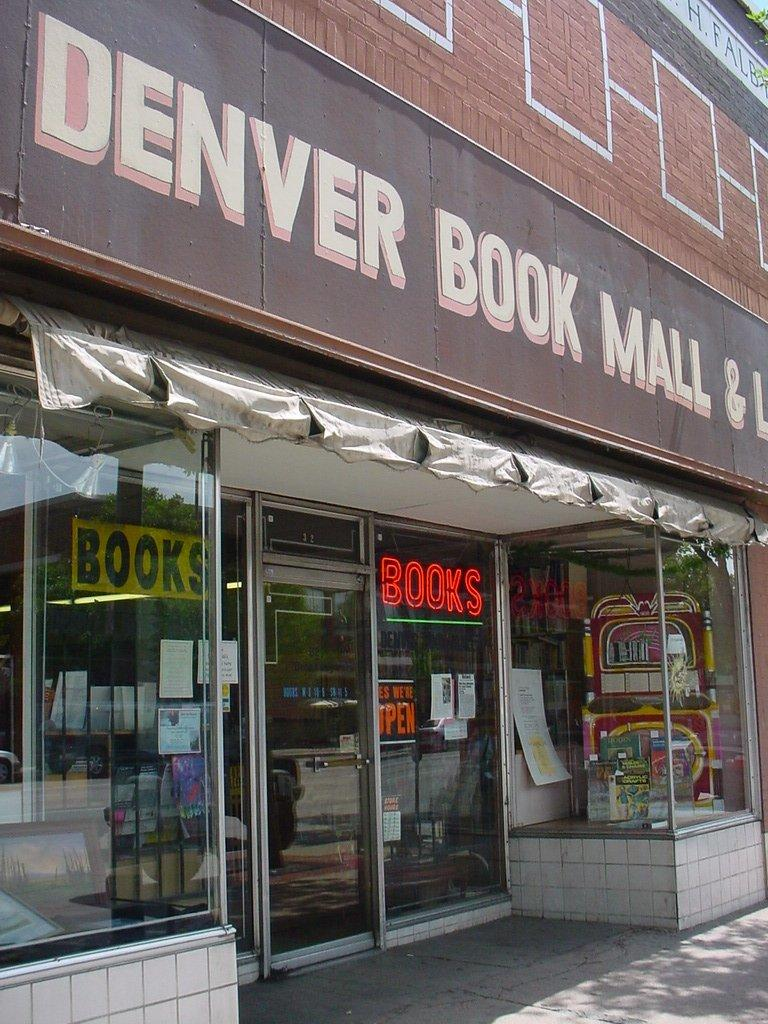<image>
Create a compact narrative representing the image presented. A book store with a neon red sign that says books. 